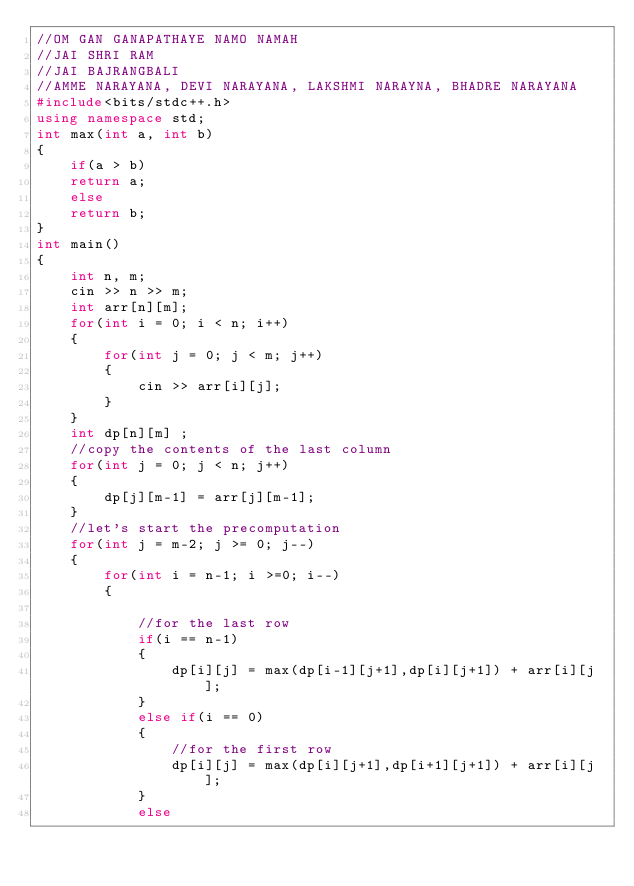<code> <loc_0><loc_0><loc_500><loc_500><_C++_>//OM GAN GANAPATHAYE NAMO NAMAH 
//JAI SHRI RAM 
//JAI BAJRANGBALI 
//AMME NARAYANA, DEVI NARAYANA, LAKSHMI NARAYNA, BHADRE NARAYANA
#include<bits/stdc++.h>
using namespace std;
int max(int a, int b)
{
    if(a > b)
    return a;
    else
    return b;
}
int main()
{
    int n, m;
    cin >> n >> m;
    int arr[n][m];
    for(int i = 0; i < n; i++)
    {
        for(int j = 0; j < m; j++)
        {
            cin >> arr[i][j];
        }
    }
    int dp[n][m] ;
    //copy the contents of the last column 
    for(int j = 0; j < n; j++)
    {
        dp[j][m-1] = arr[j][m-1];
    }
    //let's start the precomputation 
    for(int j = m-2; j >= 0; j--)
    {
        for(int i = n-1; i >=0; i--)
        {
            
            //for the last row 
            if(i == n-1)
            {
                dp[i][j] = max(dp[i-1][j+1],dp[i][j+1]) + arr[i][j];
            }
            else if(i == 0)
            {
                //for the first row 
                dp[i][j] = max(dp[i][j+1],dp[i+1][j+1]) + arr[i][j];
            }
            else</code> 